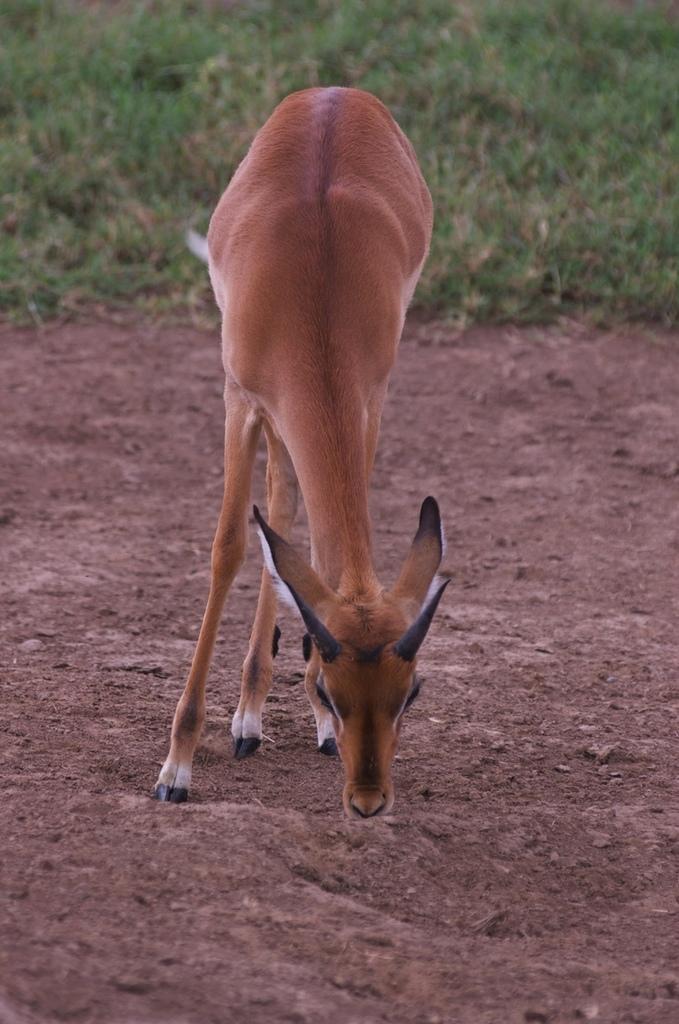Can you describe this image briefly? In the picture I can see donkey on the ground, behind we can see grass. 